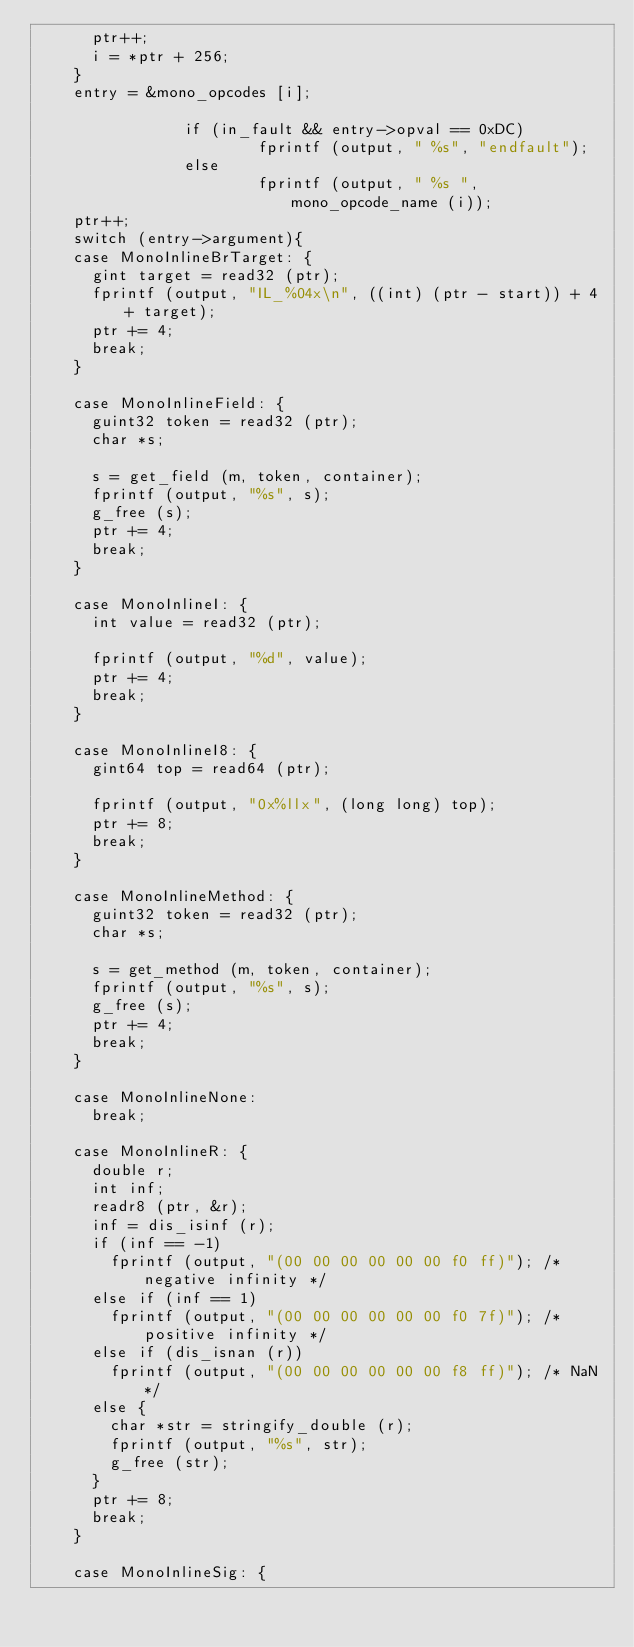<code> <loc_0><loc_0><loc_500><loc_500><_C_>			ptr++;
			i = *ptr + 256;
		} 
		entry = &mono_opcodes [i];

                if (in_fault && entry->opval == 0xDC)
                        fprintf (output, " %s", "endfault");
                else
                        fprintf (output, " %s ", mono_opcode_name (i));
		ptr++;
		switch (entry->argument){
		case MonoInlineBrTarget: {
			gint target = read32 (ptr);
			fprintf (output, "IL_%04x\n", ((int) (ptr - start)) + 4 + target);
			ptr += 4;
			break;
		}
			
		case MonoInlineField: {
			guint32 token = read32 (ptr);
			char *s;
			
			s = get_field (m, token, container);
			fprintf (output, "%s", s);
			g_free (s);
			ptr += 4;
			break;
		}
		
		case MonoInlineI: {
			int value = read32 (ptr);

			fprintf (output, "%d", value);
			ptr += 4;
			break;
		}
		
		case MonoInlineI8: {
			gint64 top = read64 (ptr);

			fprintf (output, "0x%llx", (long long) top);
			ptr += 8;
			break;
		}
		
		case MonoInlineMethod: {
			guint32 token = read32 (ptr);
			char *s;

			s = get_method (m, token, container);
			fprintf (output, "%s", s);
			g_free (s);
			ptr += 4;
			break;
		}
		
		case MonoInlineNone:
			break;
			
		case MonoInlineR: {
			double r;
			int inf;
			readr8 (ptr, &r);
			inf = dis_isinf (r);
			if (inf == -1) 
				fprintf (output, "(00 00 00 00 00 00 f0 ff)"); /* negative infinity */
			else if (inf == 1)
				fprintf (output, "(00 00 00 00 00 00 f0 7f)"); /* positive infinity */
			else if (dis_isnan (r))
				fprintf (output, "(00 00 00 00 00 00 f8 ff)"); /* NaN */
			else {
				char *str = stringify_double (r);
				fprintf (output, "%s", str);
				g_free (str);
			}
			ptr += 8;
			break;
		}
		
		case MonoInlineSig: {</code> 